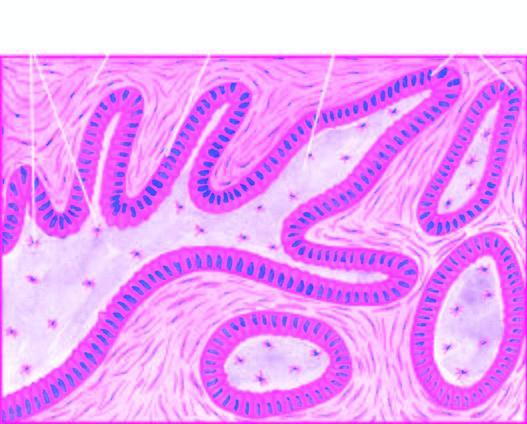what show central cystic change?
Answer the question using a single word or phrase. Plexiform areas 